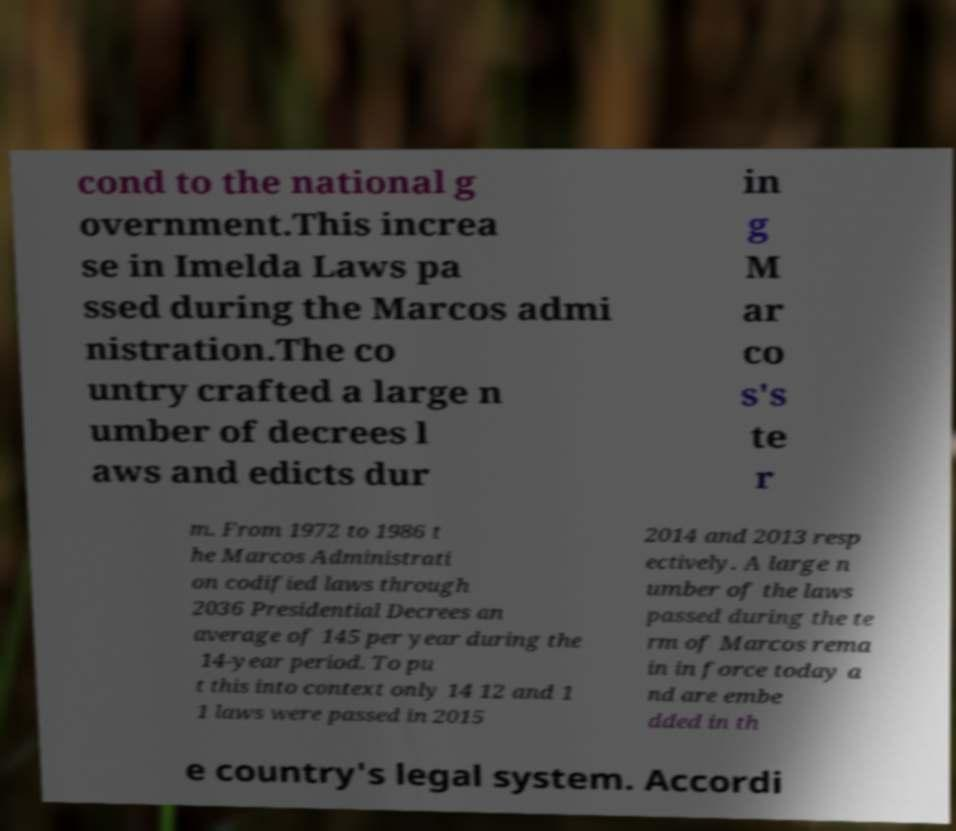Please read and relay the text visible in this image. What does it say? cond to the national g overnment.This increa se in Imelda Laws pa ssed during the Marcos admi nistration.The co untry crafted a large n umber of decrees l aws and edicts dur in g M ar co s's te r m. From 1972 to 1986 t he Marcos Administrati on codified laws through 2036 Presidential Decrees an average of 145 per year during the 14-year period. To pu t this into context only 14 12 and 1 1 laws were passed in 2015 2014 and 2013 resp ectively. A large n umber of the laws passed during the te rm of Marcos rema in in force today a nd are embe dded in th e country's legal system. Accordi 